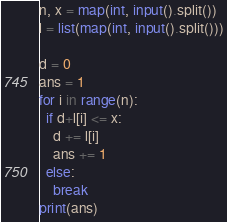Convert code to text. <code><loc_0><loc_0><loc_500><loc_500><_Python_>n, x = map(int, input().split())
l = list(map(int, input().split()))

d = 0
ans = 1
for i in range(n):
  if d+l[i] <= x:
    d += l[i]
    ans += 1
  else:
    break
print(ans)</code> 